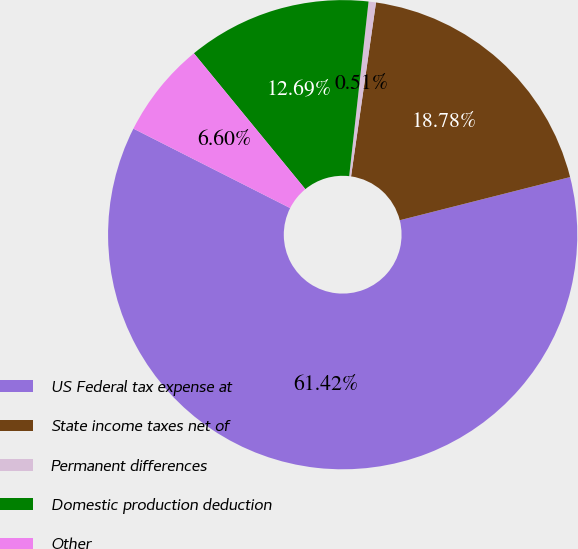Convert chart. <chart><loc_0><loc_0><loc_500><loc_500><pie_chart><fcel>US Federal tax expense at<fcel>State income taxes net of<fcel>Permanent differences<fcel>Domestic production deduction<fcel>Other<nl><fcel>61.41%<fcel>18.78%<fcel>0.51%<fcel>12.69%<fcel>6.6%<nl></chart> 